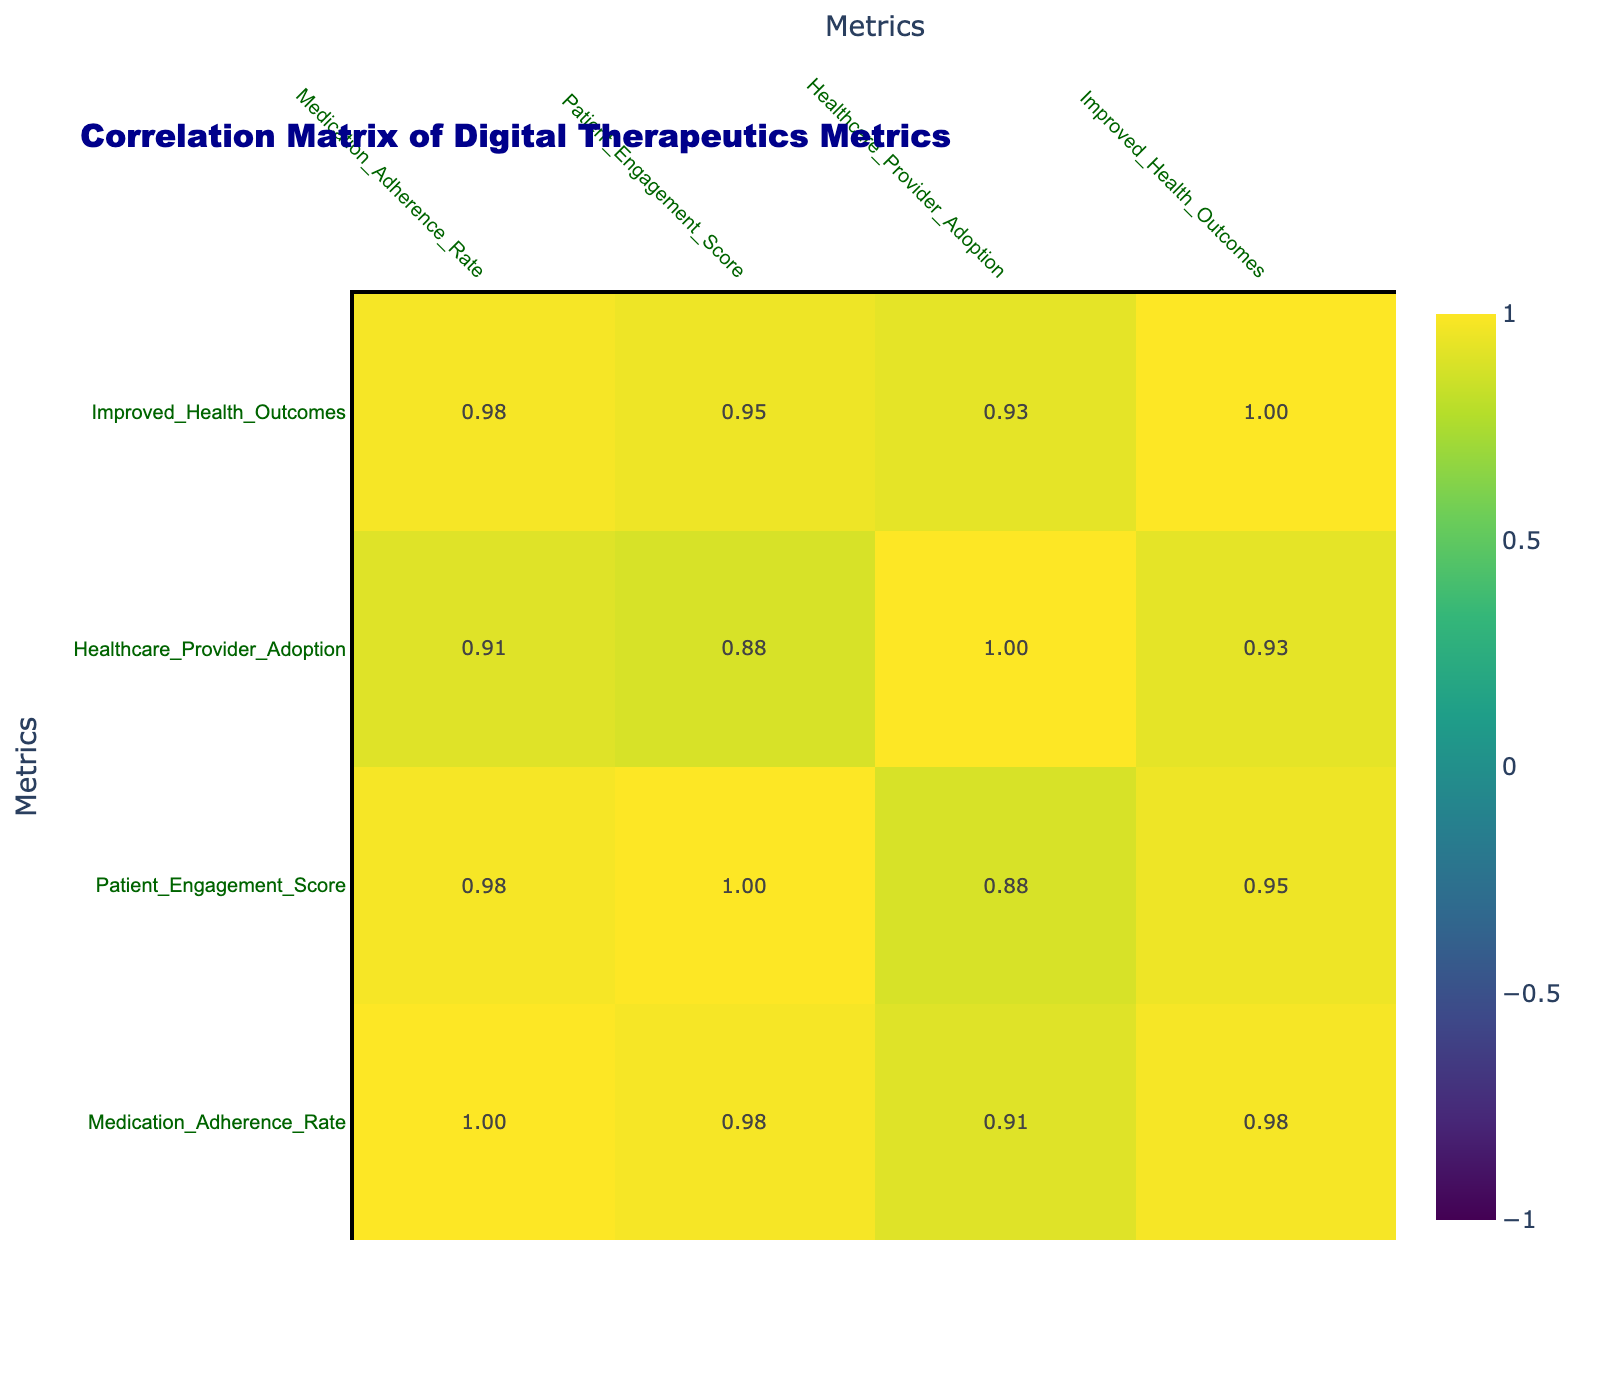What is the Medication Adherence Rate for the Hypertension Management Reminders App? The table shows a specific row for the Hypertension Management Reminders App. Looking under the Medication Adherence Rate column for this app, the value is listed as 95%.
Answer: 95% Which Digital Therapeutics has the highest Patient Engagement Score? By scanning the Patient Engagement Score column, the highest value is found under the Diabetes Glucose Monitoring App, which has a score of 80.
Answer: 80 Is the Medication Adherence Rate for Anxiety Management Virtual Reality Therapy greater than the average of all Medication Adherence Rates? First, we calculate the average of the Medication Adherence Rates: (85 + 90 + 72 + 88 + 95 + 80 + 78 + 92) / 8 = 83.75. The Medication Adherence Rate for Anxiety Management Virtual Reality Therapy is 88%, which is greater than 83.75%.
Answer: Yes What is the correlation between Patient Engagement Score and Medication Adherence Rate? In the correlation matrix, we look for the intersection of the Patient Engagement Score and Medication Adherence Rate row and column. The value found there is calculated as a correlation coefficient, which indicates the strength and direction of the relationship between these two metrics. The specific value is not given, but one would need to refer to the correlation table itself for the exact number.
Answer: (value from table) Which Digital Therapeutics has the lowest Healthcare Provider Adoption percentage? We compare all rows in the Healthcare Provider Adoption column and find that the Chronic Pain Management App has the lowest adoption rate at 60%.
Answer: 60% What is the average Medication Adherence Rate across all Digital Therapeutics listed? To find the average, sum all the Medication Adherence Rates (85 + 90 + 72 + 88 + 95 + 80 + 78 + 92) = 700. Then divide by the number of Digital Therapeutics, which is 8; hence the average is 700 / 8 = 87.5%.
Answer: 87.5% Does the Anxiety Management Virtual Reality Therapy have a higher Medication Adherence Rate than the Chronic Pain Management App? The Medication Adherence Rate for Anxiety Management Virtual Reality Therapy is listed as 88%, while the Chronic Pain Management App has 72%. Comparing these two values, 88% is greater than 72%.
Answer: Yes What is the difference in Healthcare Provider Adoption percentage between the highest and lowest values? The highest Healthcare Provider Adoption percentage is 95% (Hypertension Management Reminders App), and the lowest is 60% (Chronic Pain Management App). We find the difference: 95 - 60 = 35%.
Answer: 35% 